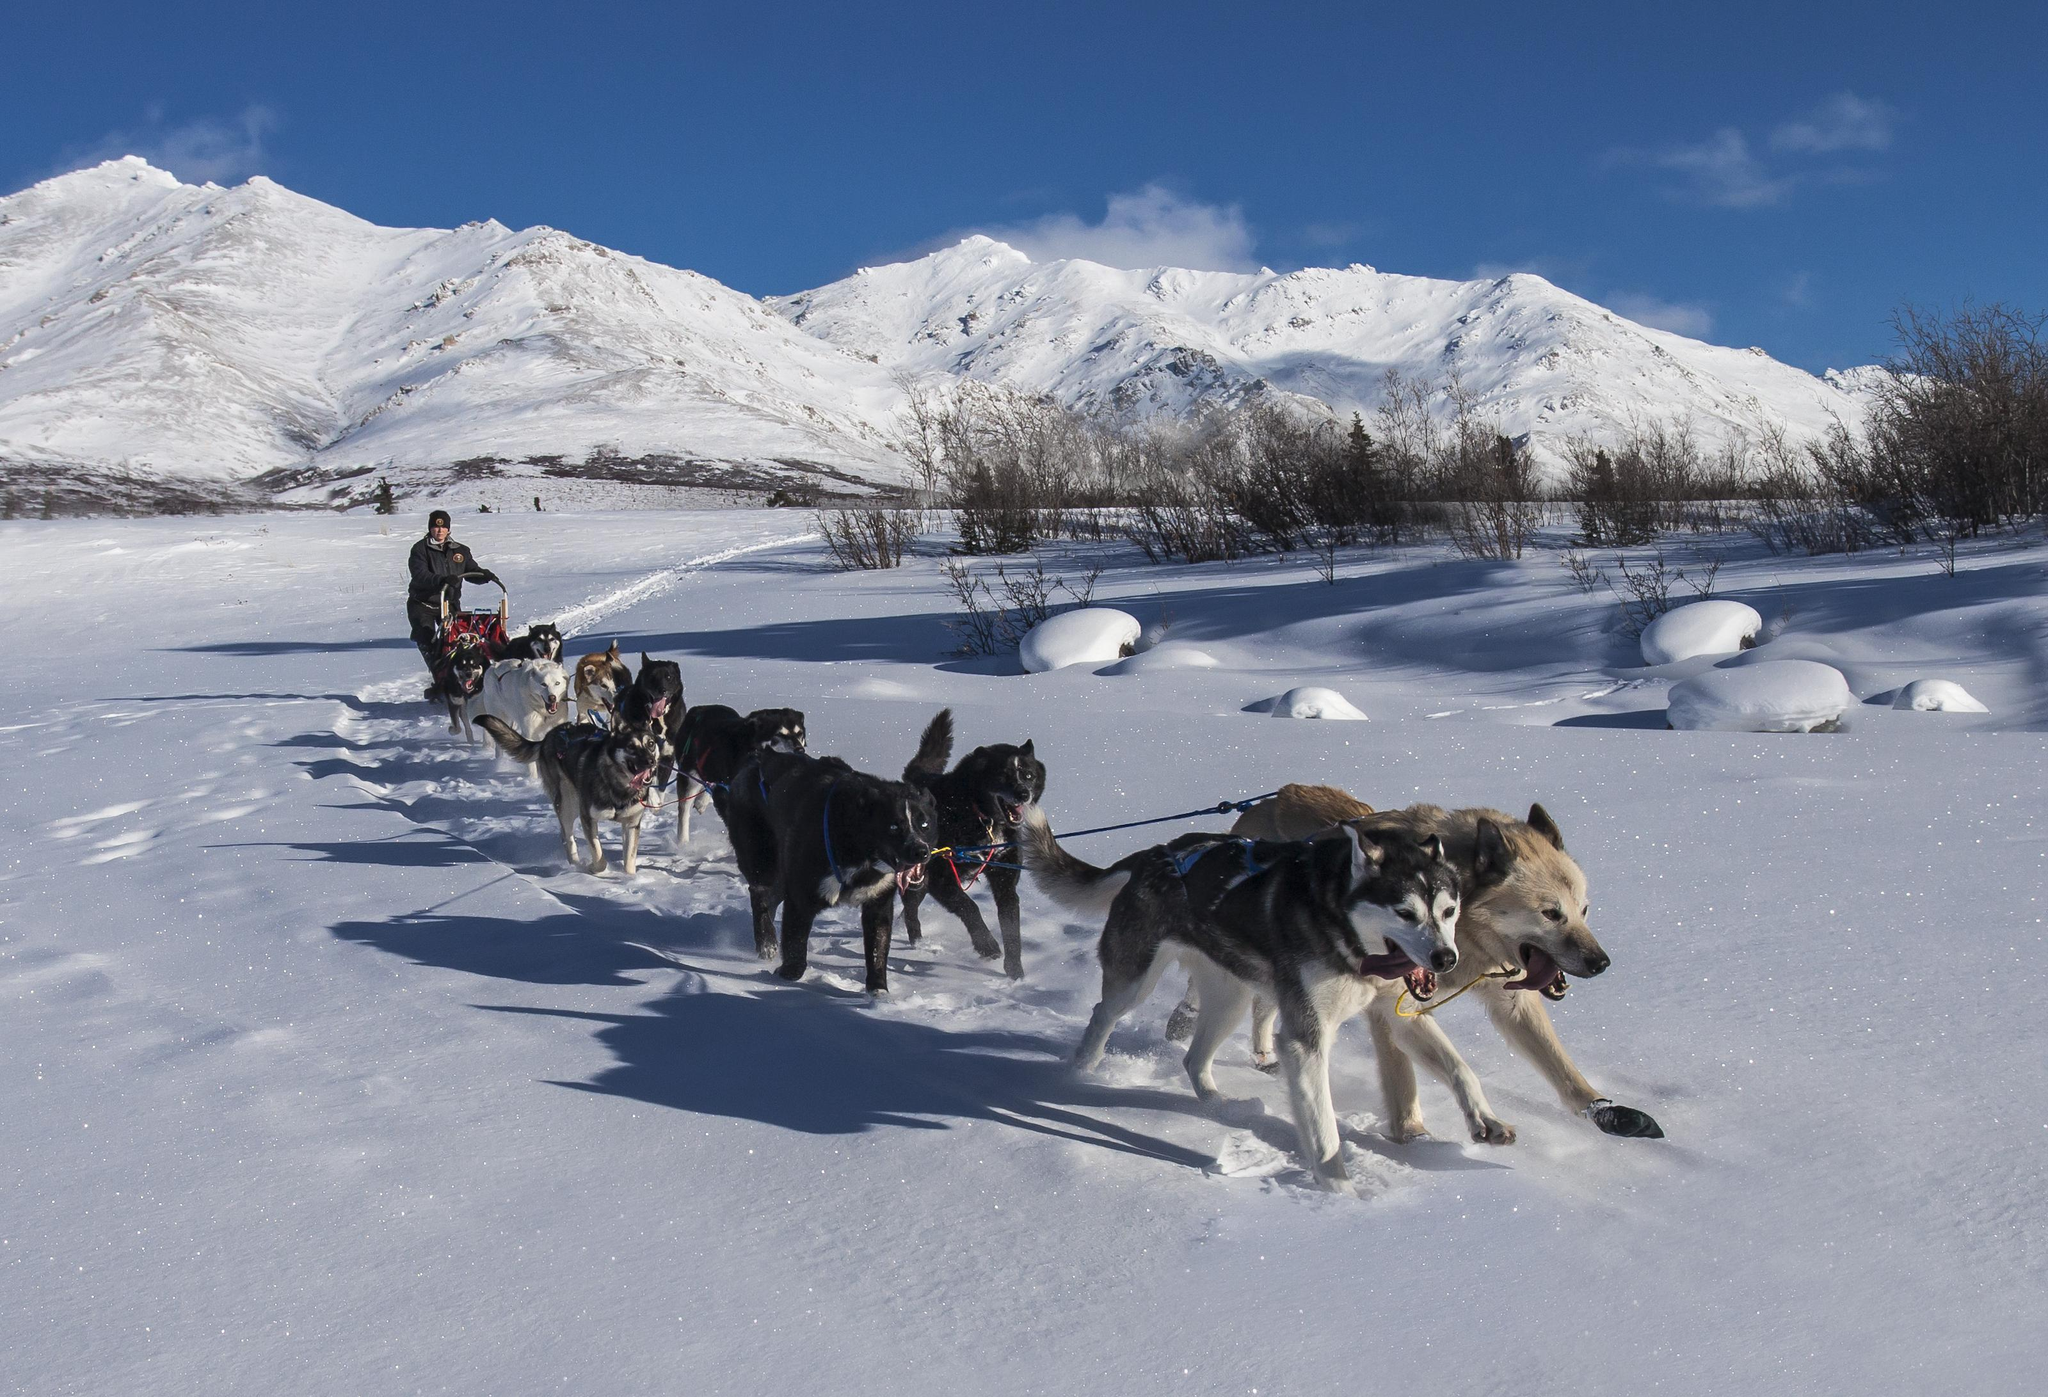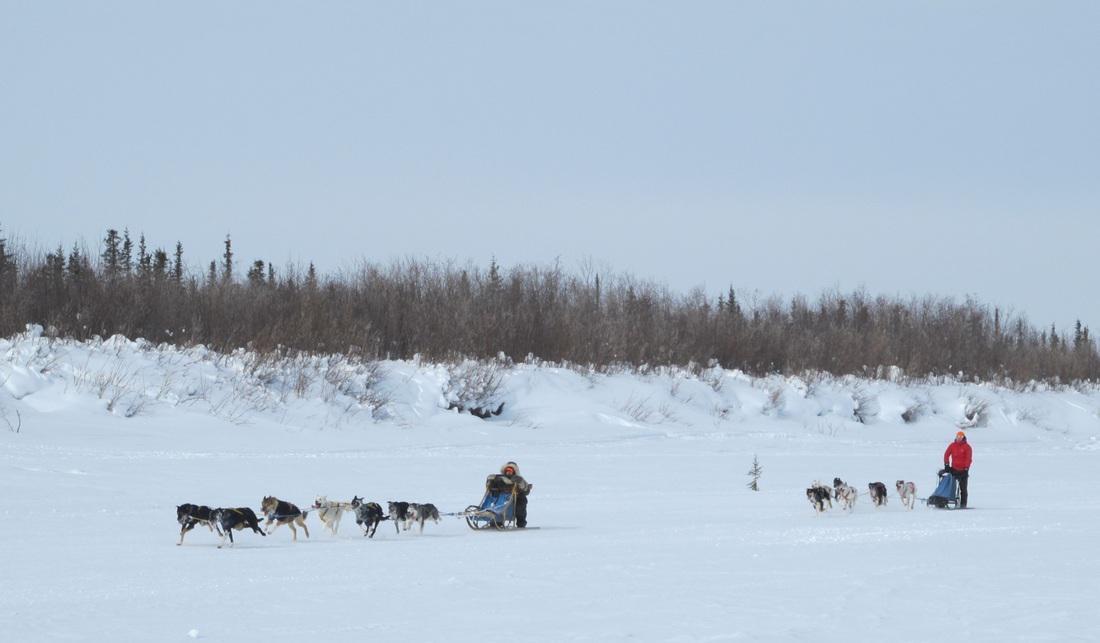The first image is the image on the left, the second image is the image on the right. Analyze the images presented: Is the assertion "In the left image, there's a single team of sled dogs running across the snow to the lower right." valid? Answer yes or no. Yes. The first image is the image on the left, the second image is the image on the right. Evaluate the accuracy of this statement regarding the images: "There is at most 2 groups of sleigh dogs pulling a sled to the left in the snow.". Is it true? Answer yes or no. Yes. 